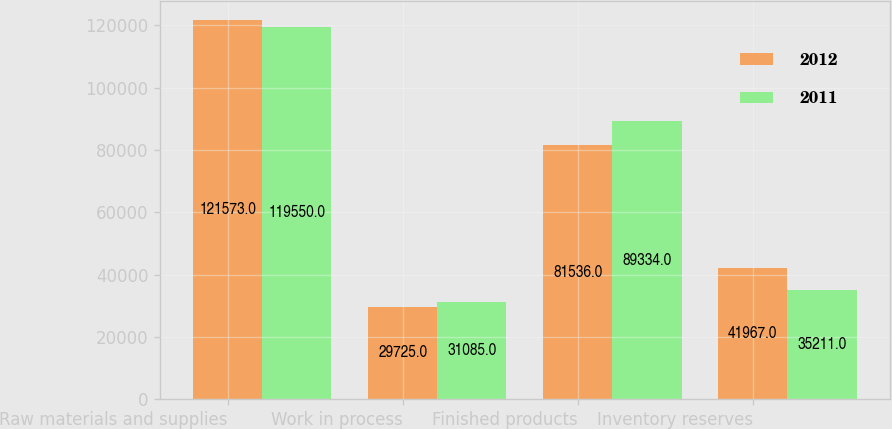<chart> <loc_0><loc_0><loc_500><loc_500><stacked_bar_chart><ecel><fcel>Raw materials and supplies<fcel>Work in process<fcel>Finished products<fcel>Inventory reserves<nl><fcel>2012<fcel>121573<fcel>29725<fcel>81536<fcel>41967<nl><fcel>2011<fcel>119550<fcel>31085<fcel>89334<fcel>35211<nl></chart> 